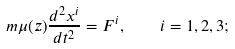<formula> <loc_0><loc_0><loc_500><loc_500>m \mu ( z ) \frac { d ^ { 2 } x ^ { i } } { d t ^ { 2 } } = F ^ { i } , \quad i = 1 , 2 , 3 ;</formula> 